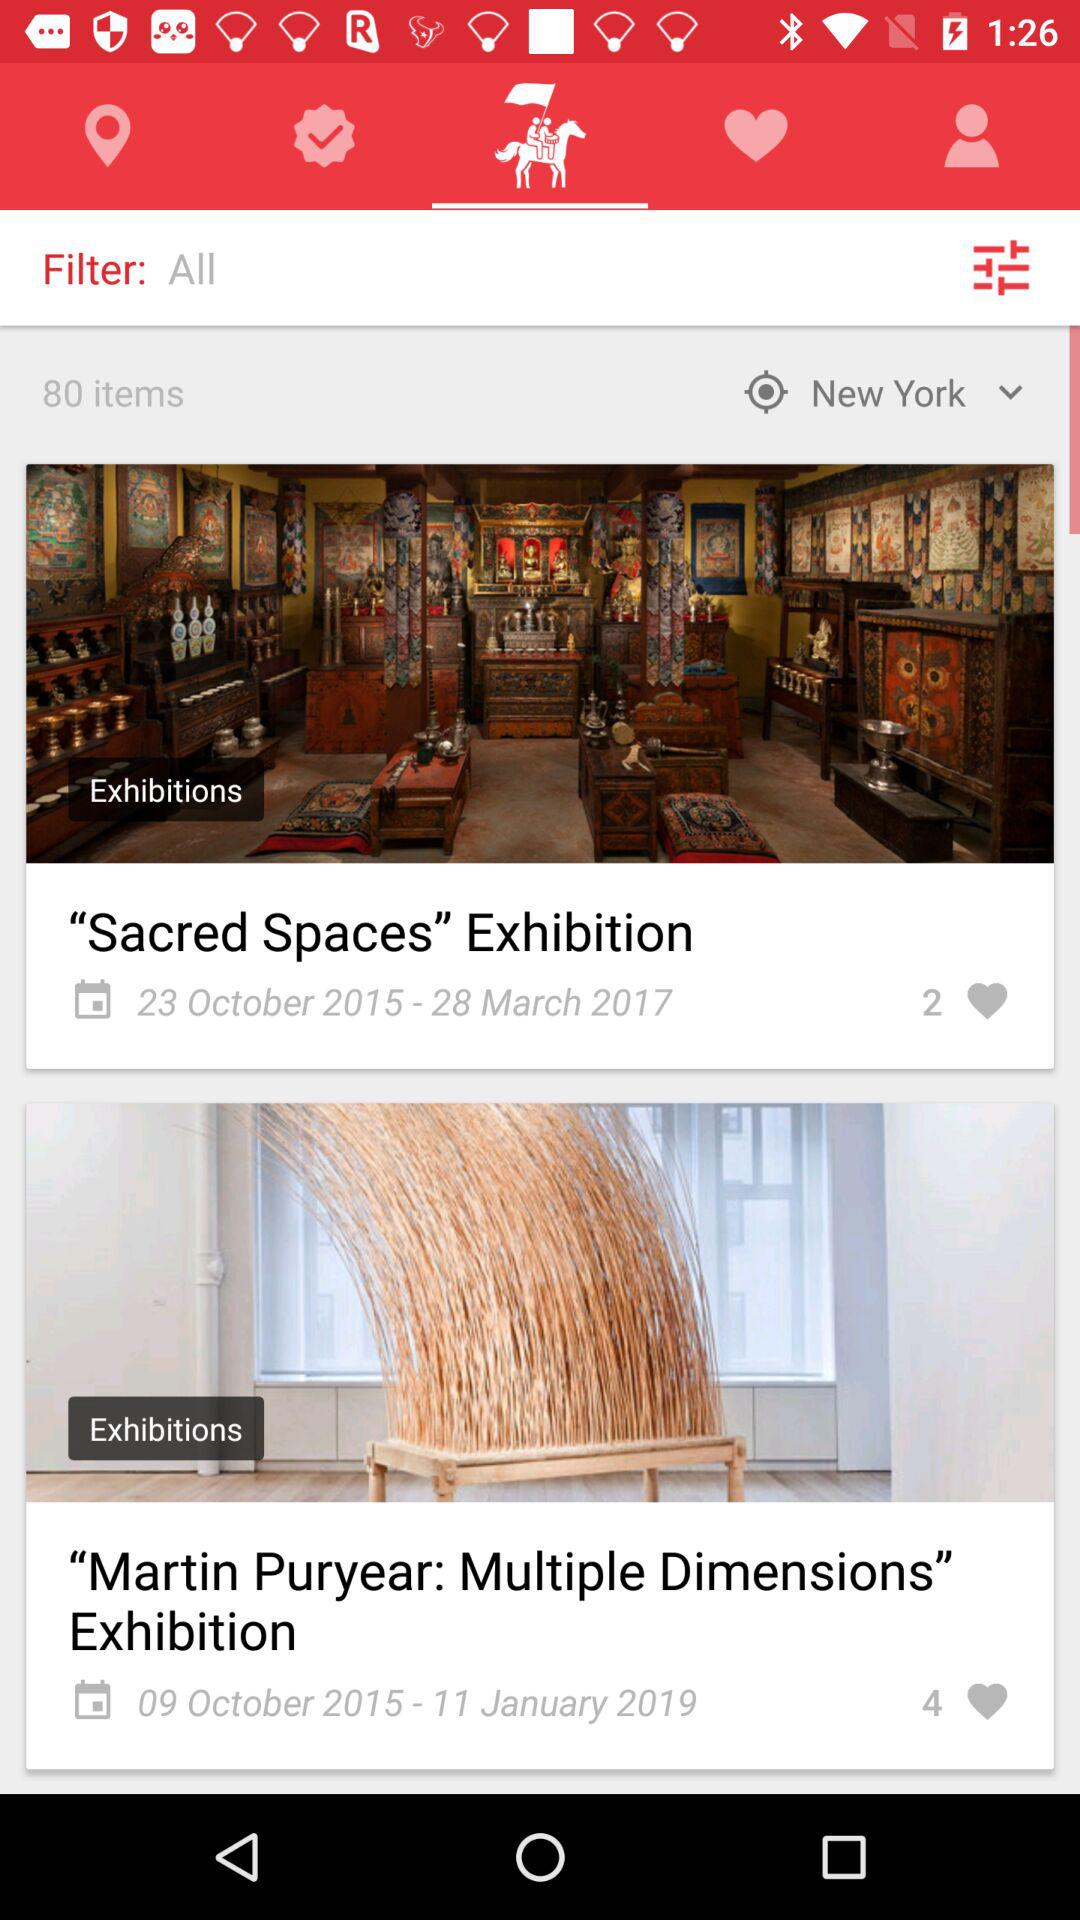How many total items were found? There were 80 items found. 